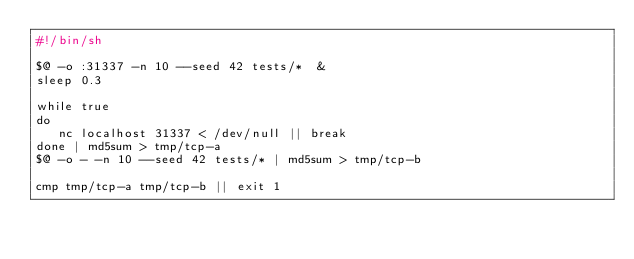<code> <loc_0><loc_0><loc_500><loc_500><_Bash_>#!/bin/sh

$@ -o :31337 -n 10 --seed 42 tests/*  &
sleep 0.3

while true
do
   nc localhost 31337 < /dev/null || break
done | md5sum > tmp/tcp-a
$@ -o - -n 10 --seed 42 tests/* | md5sum > tmp/tcp-b

cmp tmp/tcp-a tmp/tcp-b || exit 1
</code> 